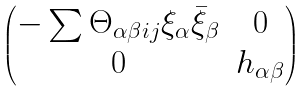Convert formula to latex. <formula><loc_0><loc_0><loc_500><loc_500>\begin{pmatrix} - \sum \Theta _ { \alpha \beta i j } \xi _ { \alpha } \bar { \xi } _ { \beta } & 0 \\ 0 & h _ { \alpha \beta } \end{pmatrix}</formula> 